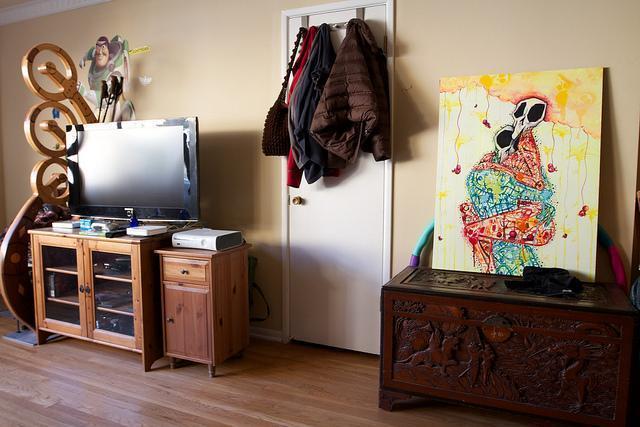How many elephants are visible?
Give a very brief answer. 0. 